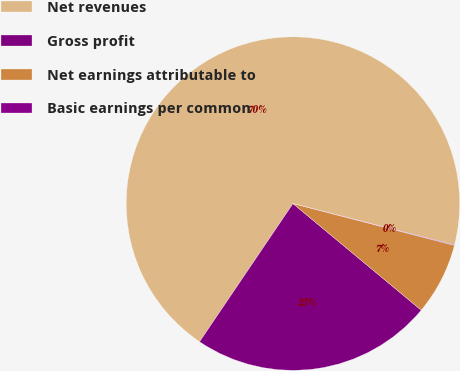<chart> <loc_0><loc_0><loc_500><loc_500><pie_chart><fcel>Net revenues<fcel>Gross profit<fcel>Net earnings attributable to<fcel>Basic earnings per common<nl><fcel>69.53%<fcel>23.43%<fcel>7.0%<fcel>0.05%<nl></chart> 